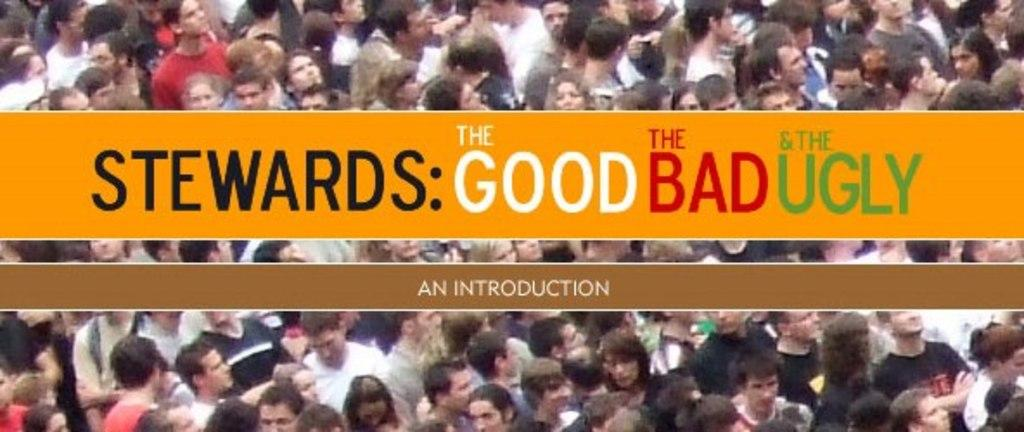How many people are in the image? There is a group of people in the image, but the exact number cannot be determined without more information. What can be seen on the surface in the image? There is text on an orange and brown surface in the image. How many bricks are stacked on top of each other in the image? There are no bricks present in the image. What type of apples can be seen in the pail in the image? There is no pail or apples present in the image. 